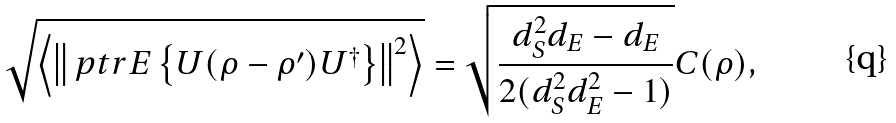Convert formula to latex. <formula><loc_0><loc_0><loc_500><loc_500>\sqrt { \left \langle \left \| \ p t r { E } \left \{ U ( \rho - \rho ^ { \prime } ) U ^ { \dagger } \right \} \right \| ^ { 2 } \right \rangle } = \sqrt { \frac { d _ { S } ^ { 2 } d _ { E } - d _ { E } } { 2 ( d _ { S } ^ { 2 } d _ { E } ^ { 2 } - 1 ) } } C ( \rho ) ,</formula> 